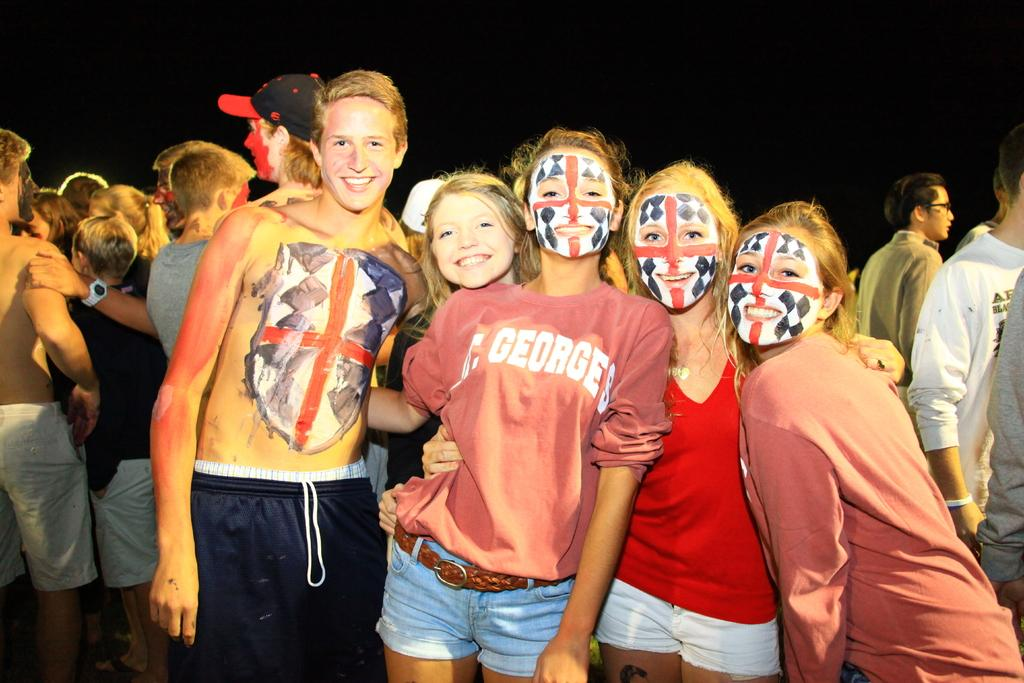How many people are in the image? There are people in the image, but the exact number is not specified. What are some of the people doing in the image? Some of the people are standing, and some of them are smiling. What is on the faces of some people in the image? There is painting on the faces of some people in the image. What can be observed about the background of the image? The background of the image is dark. Reasoning: Let's think step by breaking down the conversation step by step. We start by acknowledging the presence of people in the image, but we don't specify the exact number since it's not mentioned in the facts. Then, we describe the actions of some of the people, such as standing and smiling. Next, we mention the unique detail of the painting on the faces of some people. Finally, we address the background of the image, which is described as dark. Absurd Question/Answer: What type of powder is being used by the people in the image? There is no mention of powder in the image, so it cannot be determined what type of powder, if any, is being used. 